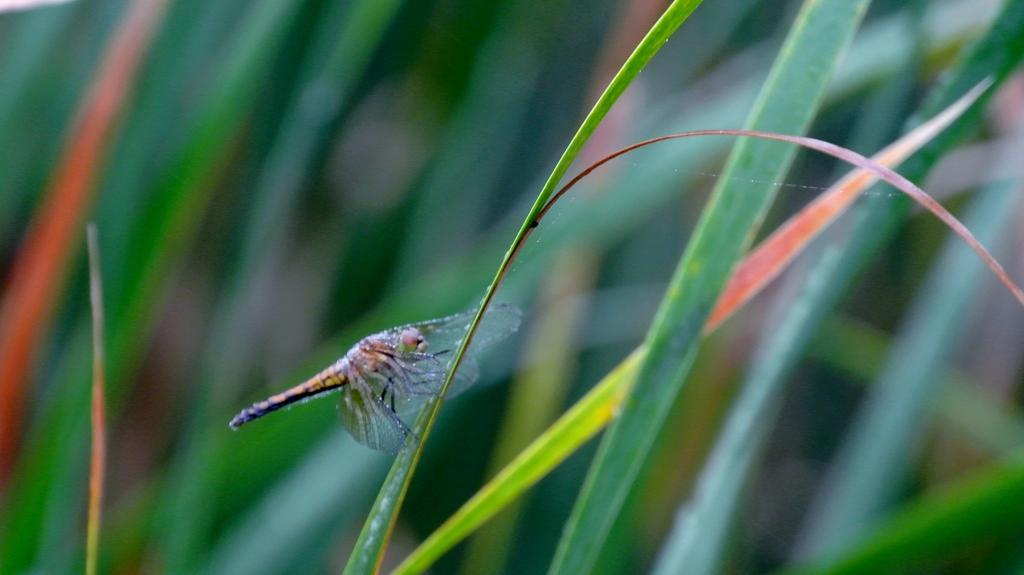What is on the leaf in the image? There is a fly on a leaf in the image. What can be seen in the background of the image? There are leaves in the background of the image. What type of bun is being used as a hat by the beetle in the image? There is no beetle or bun present in the image; it only features a fly on a leaf. What type of celery can be seen growing in the image? There is no celery present in the image; it only features a fly on a leaf and leaves in the background. 